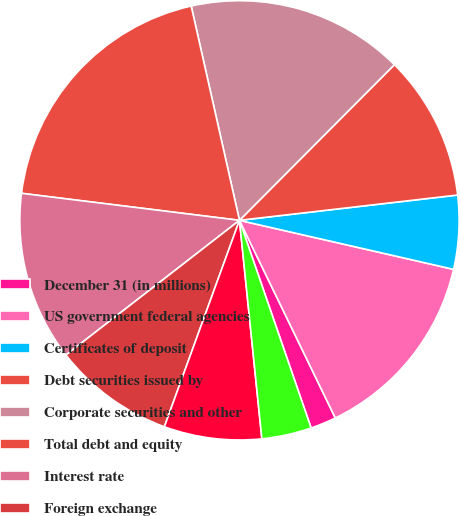Convert chart to OTSL. <chart><loc_0><loc_0><loc_500><loc_500><pie_chart><fcel>December 31 (in millions)<fcel>US government federal agencies<fcel>Certificates of deposit<fcel>Debt securities issued by<fcel>Corporate securities and other<fcel>Total debt and equity<fcel>Interest rate<fcel>Foreign exchange<fcel>Equity<fcel>Credit derivatives<nl><fcel>1.9%<fcel>14.23%<fcel>5.42%<fcel>10.7%<fcel>15.99%<fcel>19.51%<fcel>12.47%<fcel>8.94%<fcel>7.18%<fcel>3.66%<nl></chart> 